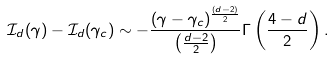<formula> <loc_0><loc_0><loc_500><loc_500>\mathcal { I } _ { d } ( \gamma ) - \mathcal { I } _ { d } ( \gamma _ { c } ) \sim - \frac { ( \gamma - \gamma _ { c } ) ^ { \frac { ( d - 2 ) } { 2 } } } { \left ( \frac { d - 2 } { 2 } \right ) } \Gamma \left ( \frac { 4 - d } { 2 } \right ) .</formula> 